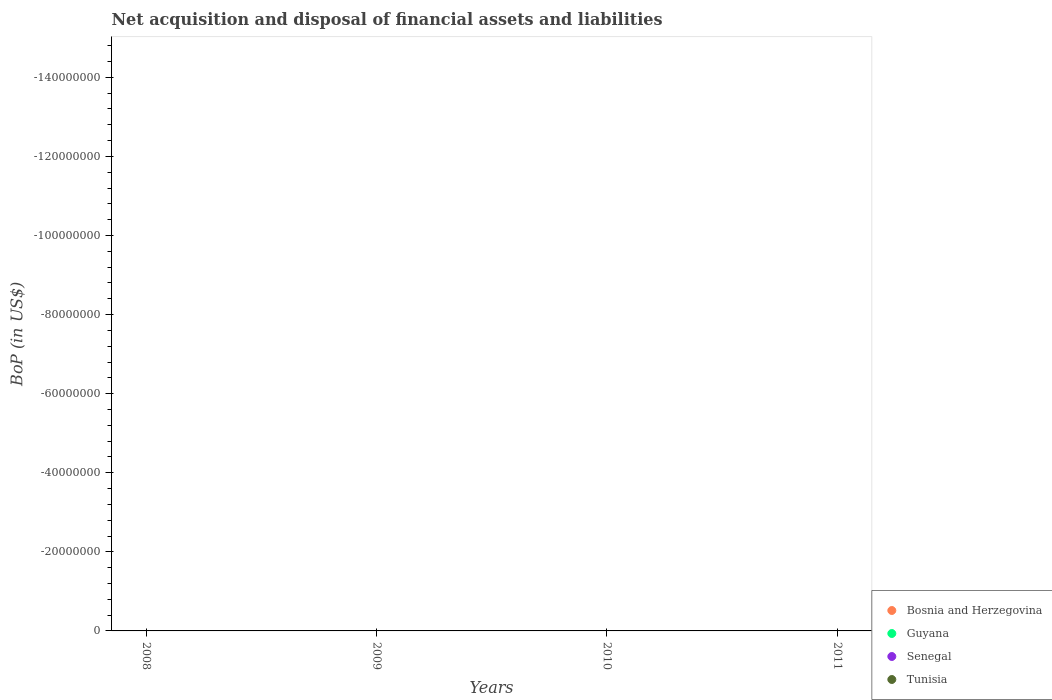How many different coloured dotlines are there?
Offer a terse response. 0. What is the Balance of Payments in Bosnia and Herzegovina in 2008?
Your response must be concise. 0. Across all years, what is the minimum Balance of Payments in Bosnia and Herzegovina?
Keep it short and to the point. 0. In how many years, is the Balance of Payments in Senegal greater than the average Balance of Payments in Senegal taken over all years?
Provide a short and direct response. 0. Is it the case that in every year, the sum of the Balance of Payments in Guyana and Balance of Payments in Tunisia  is greater than the Balance of Payments in Senegal?
Your answer should be very brief. No. Is the Balance of Payments in Guyana strictly less than the Balance of Payments in Tunisia over the years?
Your answer should be very brief. No. How many dotlines are there?
Your answer should be compact. 0. Are the values on the major ticks of Y-axis written in scientific E-notation?
Provide a short and direct response. No. Does the graph contain grids?
Keep it short and to the point. No. Where does the legend appear in the graph?
Offer a very short reply. Bottom right. How many legend labels are there?
Offer a terse response. 4. What is the title of the graph?
Offer a terse response. Net acquisition and disposal of financial assets and liabilities. Does "Montenegro" appear as one of the legend labels in the graph?
Your answer should be compact. No. What is the label or title of the X-axis?
Provide a short and direct response. Years. What is the label or title of the Y-axis?
Ensure brevity in your answer.  BoP (in US$). What is the BoP (in US$) of Bosnia and Herzegovina in 2008?
Your response must be concise. 0. What is the BoP (in US$) of Tunisia in 2008?
Your answer should be very brief. 0. What is the BoP (in US$) of Guyana in 2009?
Offer a terse response. 0. What is the BoP (in US$) in Senegal in 2009?
Provide a short and direct response. 0. What is the BoP (in US$) in Bosnia and Herzegovina in 2010?
Offer a very short reply. 0. What is the BoP (in US$) of Senegal in 2010?
Ensure brevity in your answer.  0. What is the BoP (in US$) in Tunisia in 2010?
Keep it short and to the point. 0. What is the total BoP (in US$) of Bosnia and Herzegovina in the graph?
Ensure brevity in your answer.  0. What is the total BoP (in US$) of Tunisia in the graph?
Provide a short and direct response. 0. What is the average BoP (in US$) in Senegal per year?
Offer a very short reply. 0. What is the average BoP (in US$) of Tunisia per year?
Keep it short and to the point. 0. 